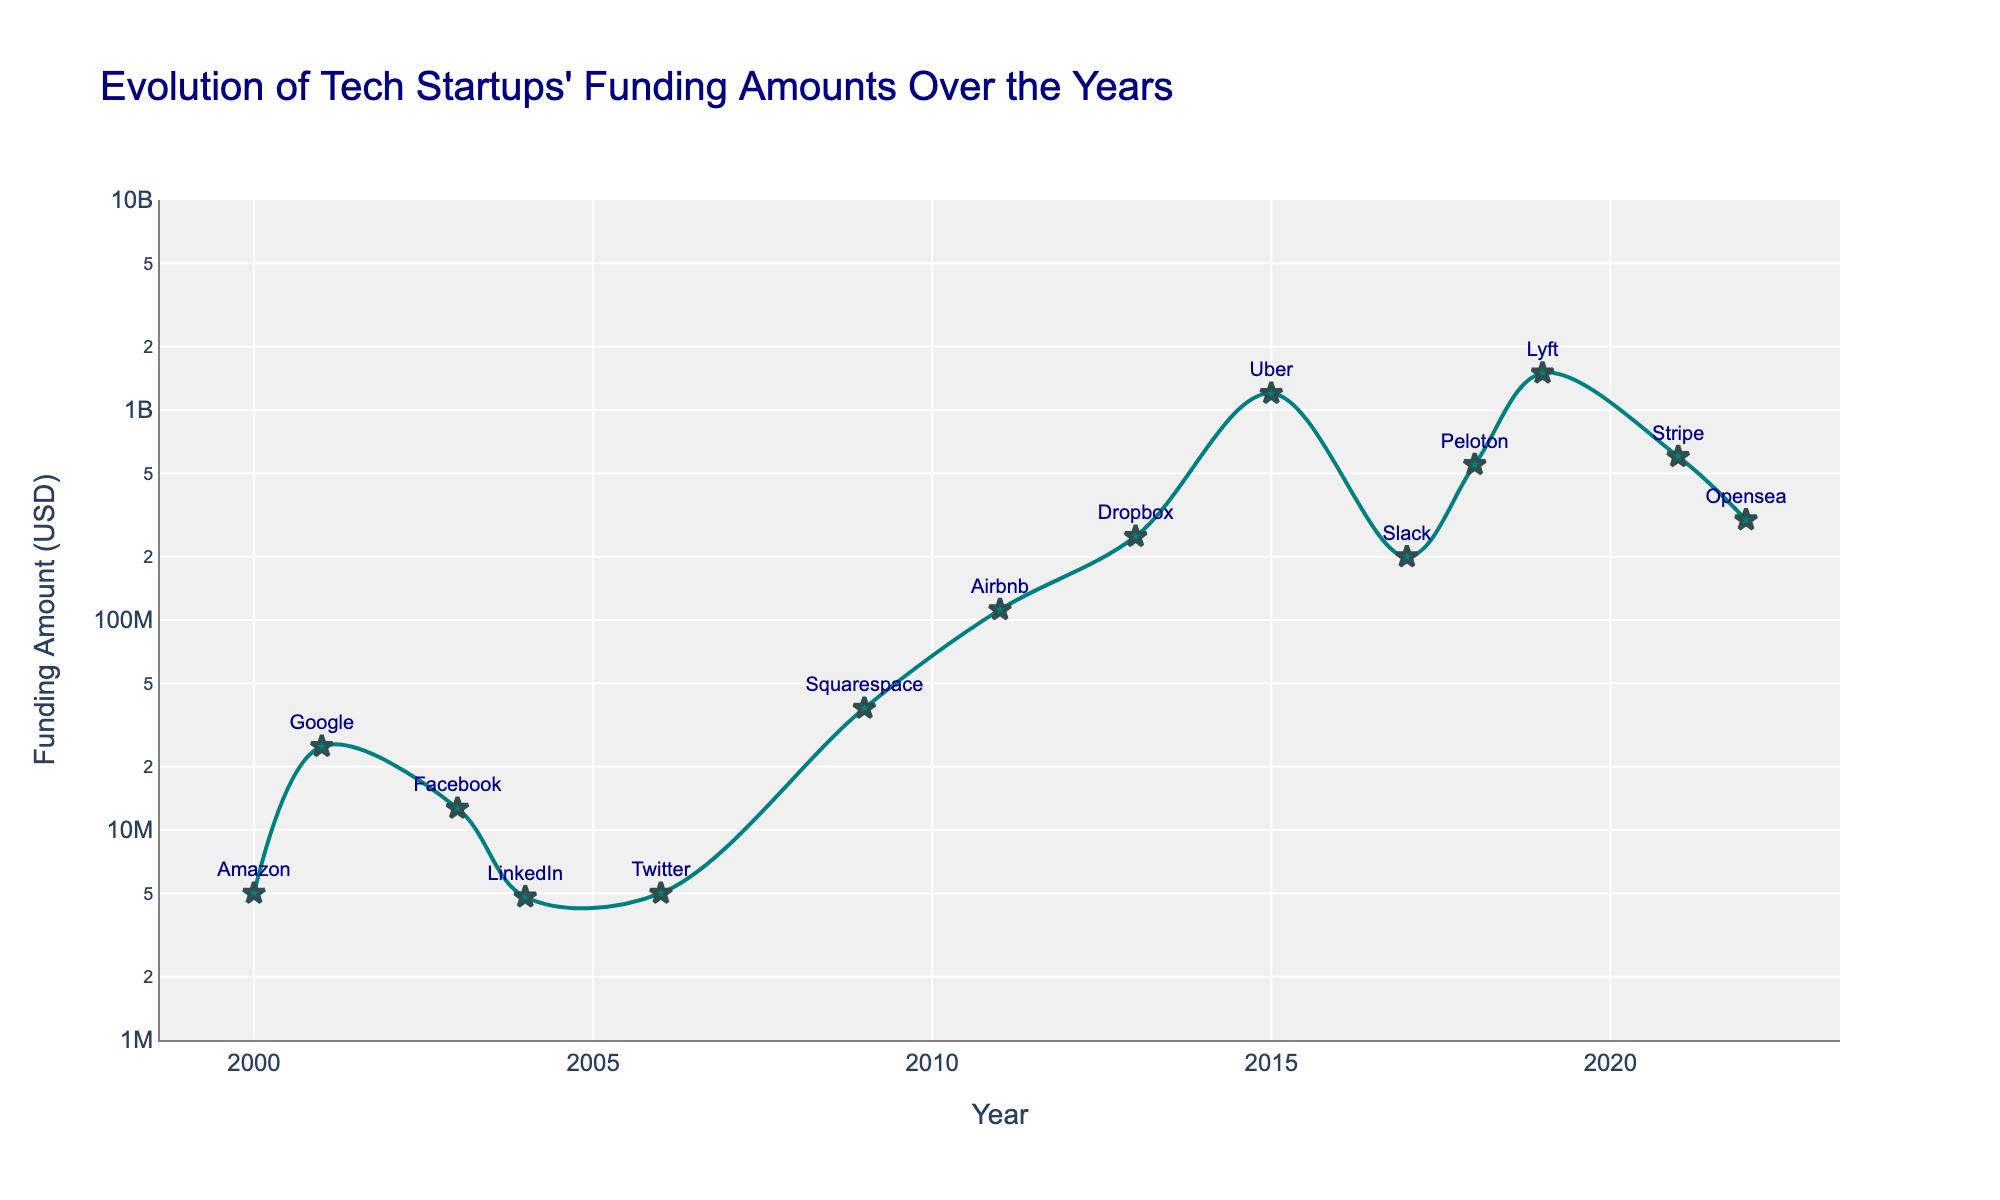What is the title of the figure? The title is usually positioned at the top center of the figure and provides a summary of what the chart represents. The title for this figure is given right after calling the `title` parameter in the plotting function.
Answer: Evolution of Tech Startups' Funding Amounts Over the Years How many companies are displayed in the figure? To find the number of companies, identify the unique entries under the 'Company' parameter in the plot which are represented as markers along the timeline. By counting these markers, we can determine the number of companies.
Answer: 14 Which company had the highest funding amount and in which year? Identify the peak data point on the line plot, then match this data point to its corresponding company and year. The log scale of the y-axis helps to identify a significantly higher funding amount.
Answer: Uber, 2015 What is the funding amount for the company with the lowest funding on the plot? Look for the smallest data point on the y-axis since the log scale emphasizes disparities. This will correspond to the lowest funding amount.
Answer: $4,800,000 (LinkedIn, 2004) What is the trend in funding amounts over the years? Observe the overall direction of the line plot from 2000 to 2022. The general slope of the line and the position of the data points show the trend.
Answer: Increasing What is the average funding amount for the companies listed in 2015, 2018, and 2019? Identify the funding amounts for the companies in 2015, 2018, and 2019. Sum these values and divide by the number of companies to find the average funding for these years. Calculation: (1,200,000,000 + 550,000,000 + 1,500,000,000) / 3
Answer: $1,083,333,333 Which company received significantly higher funding in 2021 compared to its predecessors? Find the data point for 2021 and compare it to prior data points. This visual difference and the sudden increase indicate which company had a significantly higher funding.
Answer: Stripe Is there a year with no significant increase or decrease in funding compared to the previous year? Scan the plot for consecutive years where the data points are roughly on the same horizontal level, indicating no significant change in funding amounts.
Answer: 2000 to 2001 How did the funding amount for Dropbox in 2013 compare to Amazon in 2000? Locate the data points for Dropbox in 2013 and Amazon in 2000. Compare their y-values to determine which one is higher, emphasizing that the y-axis is on a log scale.
Answer: Dropbox had a higher funding amount On which year did a sudden spike in funding occur most noticeably? Observe the plot for a year where the line shows a sharp vertical increase, indicating a sudden spike in funding.
Answer: 2015 